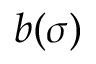Convert formula to latex. <formula><loc_0><loc_0><loc_500><loc_500>b ( \sigma )</formula> 